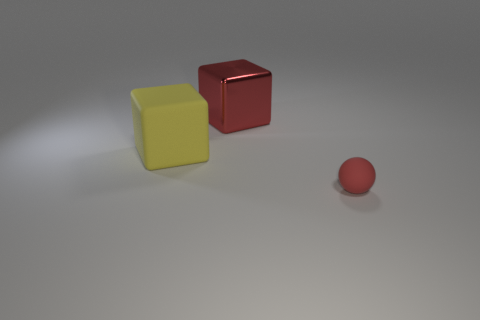Add 3 spheres. How many objects exist? 6 Subtract all spheres. How many objects are left? 2 Add 1 big matte objects. How many big matte objects exist? 2 Subtract 0 blue cubes. How many objects are left? 3 Subtract all tiny matte spheres. Subtract all large yellow cubes. How many objects are left? 1 Add 3 tiny red things. How many tiny red things are left? 4 